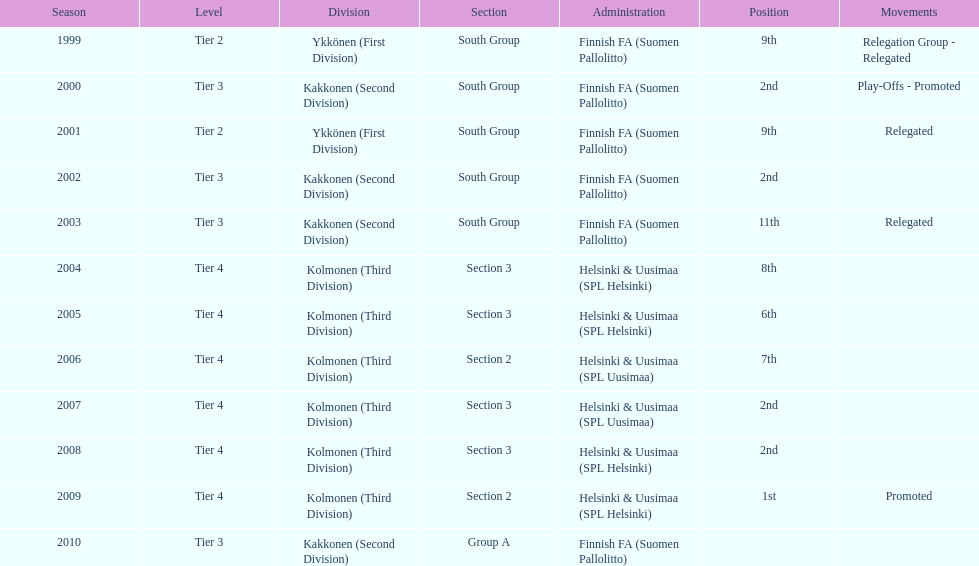How many times were they in tier 3? 4. 